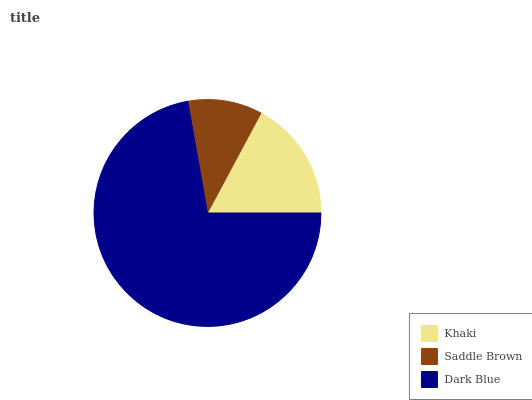Is Saddle Brown the minimum?
Answer yes or no. Yes. Is Dark Blue the maximum?
Answer yes or no. Yes. Is Dark Blue the minimum?
Answer yes or no. No. Is Saddle Brown the maximum?
Answer yes or no. No. Is Dark Blue greater than Saddle Brown?
Answer yes or no. Yes. Is Saddle Brown less than Dark Blue?
Answer yes or no. Yes. Is Saddle Brown greater than Dark Blue?
Answer yes or no. No. Is Dark Blue less than Saddle Brown?
Answer yes or no. No. Is Khaki the high median?
Answer yes or no. Yes. Is Khaki the low median?
Answer yes or no. Yes. Is Dark Blue the high median?
Answer yes or no. No. Is Dark Blue the low median?
Answer yes or no. No. 